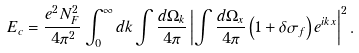Convert formula to latex. <formula><loc_0><loc_0><loc_500><loc_500>E _ { c } = \frac { e ^ { 2 } N _ { F } ^ { 2 } } { 4 \pi ^ { 2 } } \int _ { 0 } ^ { \infty } d k \int \frac { d \Omega _ { k } } { 4 \pi } \left | \int \frac { d \Omega _ { x } } { 4 \pi } \left ( 1 + \delta \sigma _ { f } \right ) e ^ { i { k } { x } } \right | ^ { 2 } .</formula> 